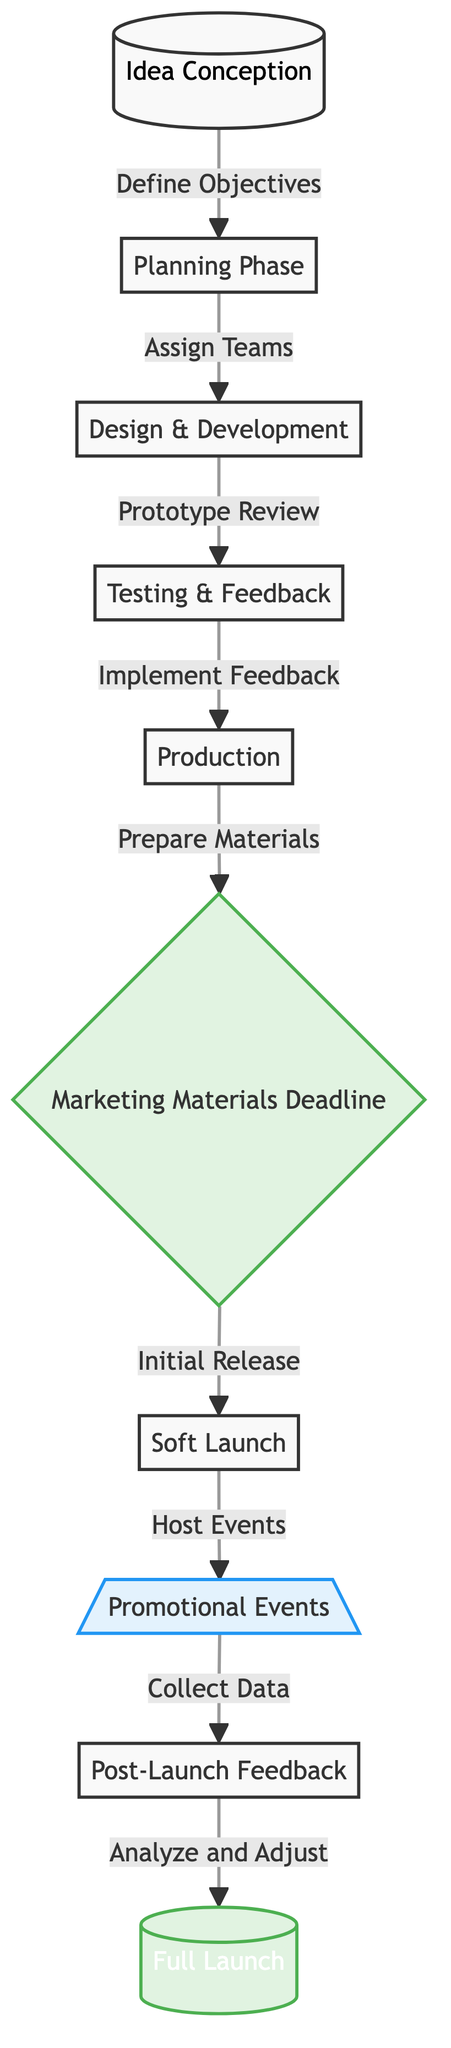What is the starting phase of the product launch timeline? The starting phase is indicated by the node labeled "Idea Conception." This node is the first in the flowchart and acts as the initial step in the timeline.
Answer: Idea Conception How many key milestones are there in this diagram? The key milestones are represented by three nodes: "Marketing Materials Deadline," "Full Launch," and "Post-Launch Feedback." By counting these specific nodes classified as milestones, we arrive at the total.
Answer: 3 What comes after the "Testing & Feedback" phase? From the flowchart, "Testing & Feedback" flows to the next node, which is "Production." This indicates the progression from testing to the production phase.
Answer: Production What is the last event listed before the full launch? The full launch occurs after the "Collect Data" step from the "Promotional Events" node. This indicates that promotional events play a crucial role leading up to the full launch.
Answer: Collect Data Which phase involves implementing feedback gathered during testing? The phase that follows "Testing & Feedback" and implements feedback is labeled as "Production." This shows that feedback is integrated during the production stage.
Answer: Production What is the primary action occurring during the "Soft Launch"? The "Soft Launch" phase is associated with hosting events, as indicated by the arrow that connects it to "Promotional Events." This highlights that events are crucial during this phase.
Answer: Host Events What is the main purpose of the "Post-Launch Feedback"? The node labeled "Post-Launch Feedback" suggests that its purpose is to collect results from the promotional events, which will lead to analyzing and adjusting strategy before the full launch.
Answer: Analyze and Adjust What is the relationship between "Marketing Materials Deadline" and "Soft Launch"? "Marketing Materials Deadline" is a milestone that directly points to "Soft Launch," indicating that the preparation of marketing materials is crucial before moving into the soft launch phase.
Answer: Direct connection What color denotes the promotional events in the diagram? The promotional events are represented by a light blue color as shown in the diagram, specifically in the node labeled "Promotional Events." This color helps distinguish these events from other elements in the timeline.
Answer: Light blue 